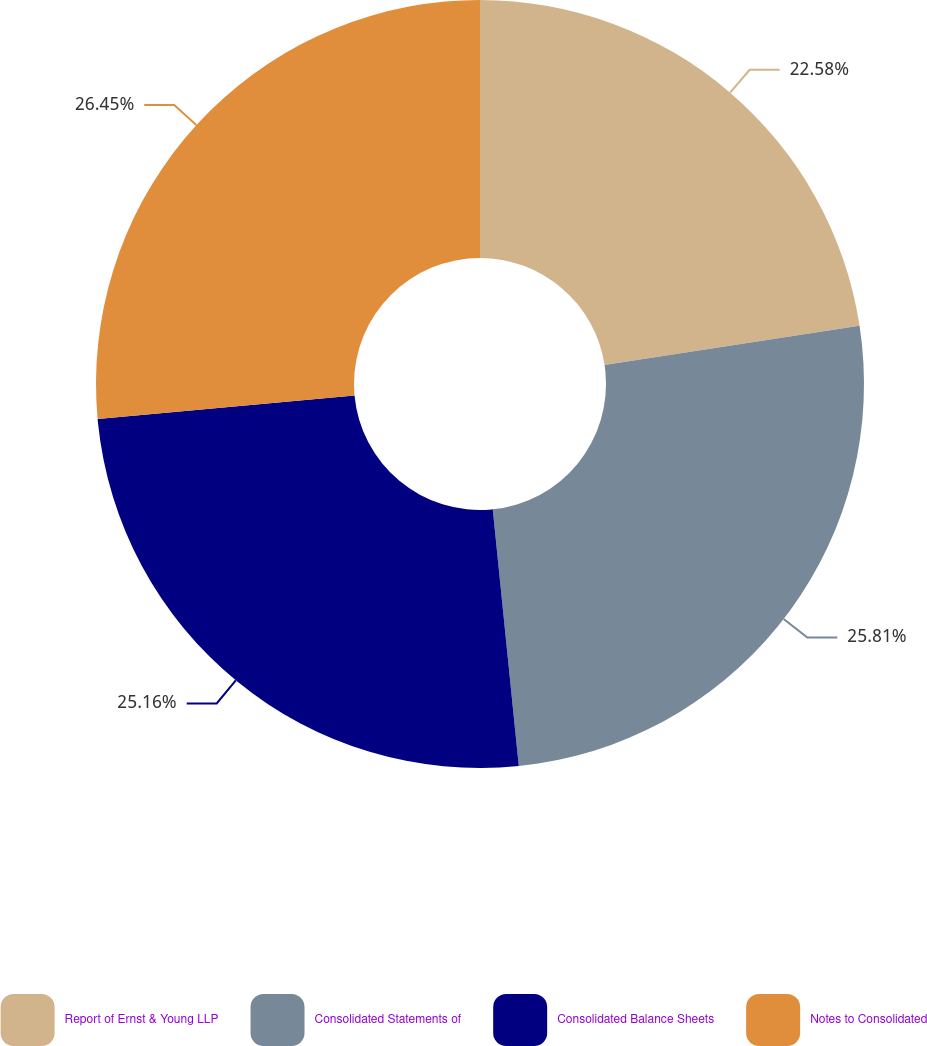Convert chart. <chart><loc_0><loc_0><loc_500><loc_500><pie_chart><fcel>Report of Ernst & Young LLP<fcel>Consolidated Statements of<fcel>Consolidated Balance Sheets<fcel>Notes to Consolidated<nl><fcel>22.58%<fcel>25.81%<fcel>25.16%<fcel>26.45%<nl></chart> 